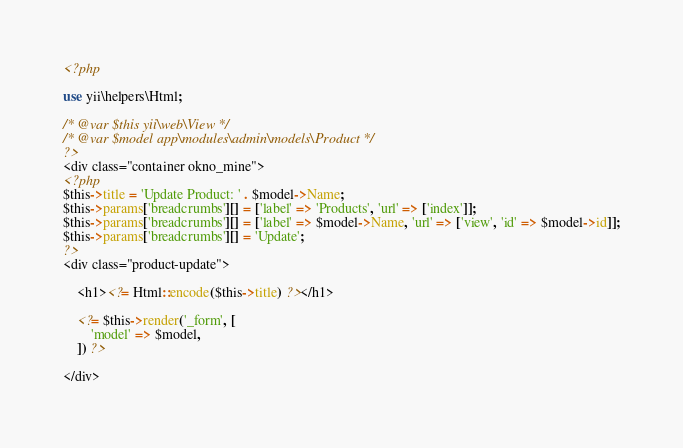<code> <loc_0><loc_0><loc_500><loc_500><_PHP_><?php

use yii\helpers\Html;

/* @var $this yii\web\View */
/* @var $model app\modules\admin\models\Product */
?>
<div class="container okno_mine">
<?php
$this->title = 'Update Product: ' . $model->Name;
$this->params['breadcrumbs'][] = ['label' => 'Products', 'url' => ['index']];
$this->params['breadcrumbs'][] = ['label' => $model->Name, 'url' => ['view', 'id' => $model->id]];
$this->params['breadcrumbs'][] = 'Update';
?>
<div class="product-update">

    <h1><?= Html::encode($this->title) ?></h1>

    <?= $this->render('_form', [
        'model' => $model,
    ]) ?>

</div>
</code> 